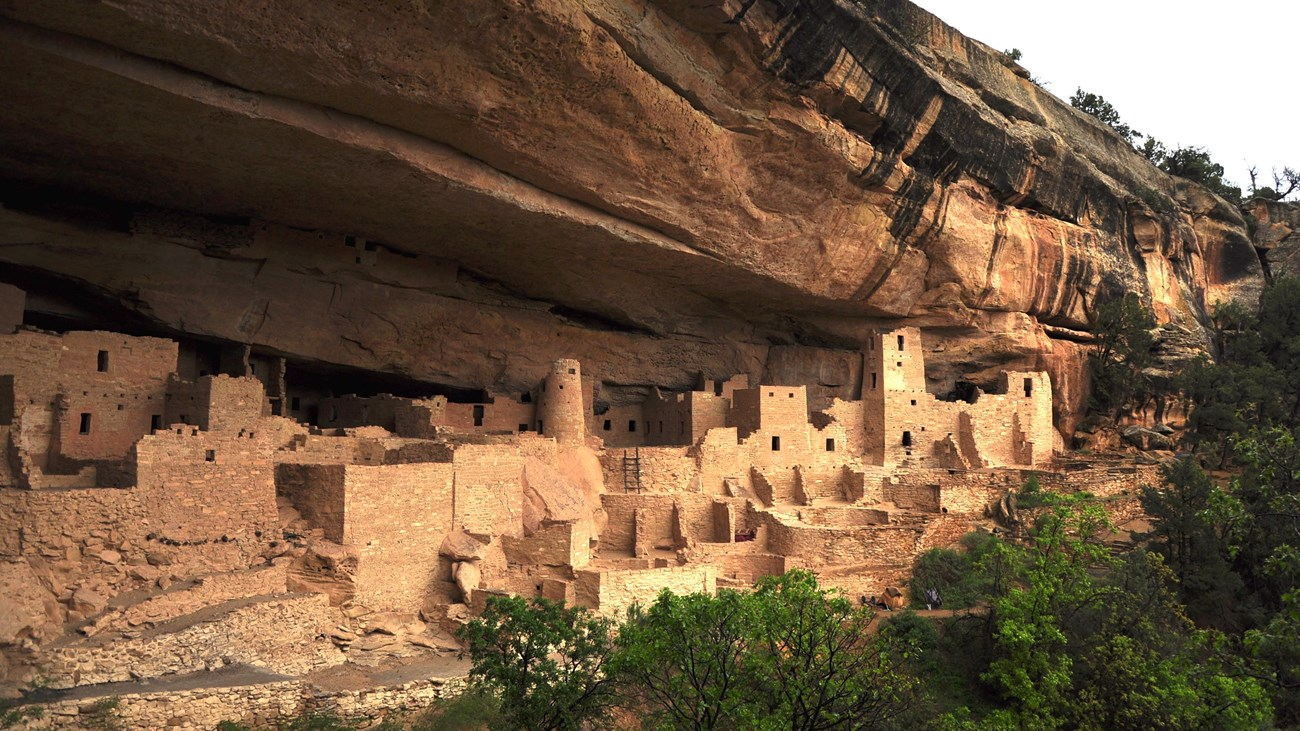How might these structures have protected the inhabitants from the elements? The cliff dwellings provided significant protection for the inhabitants from the elements. The overhanging cliff face acted as a natural shield against rain and snow, keeping the interior spaces dry. These structures also offered relief from the intense sun, providing shade during the hot summer months. In cold weather, the stone buildings retained heat from fires, creating a warmer living environment. The strategic positioning of these dwellings also offered protection from wind and other natural elements, ensuring a stable and secure habitat for the ancient Puebloan people, while their elevated location safeguarded them from potential threats or intruders. 